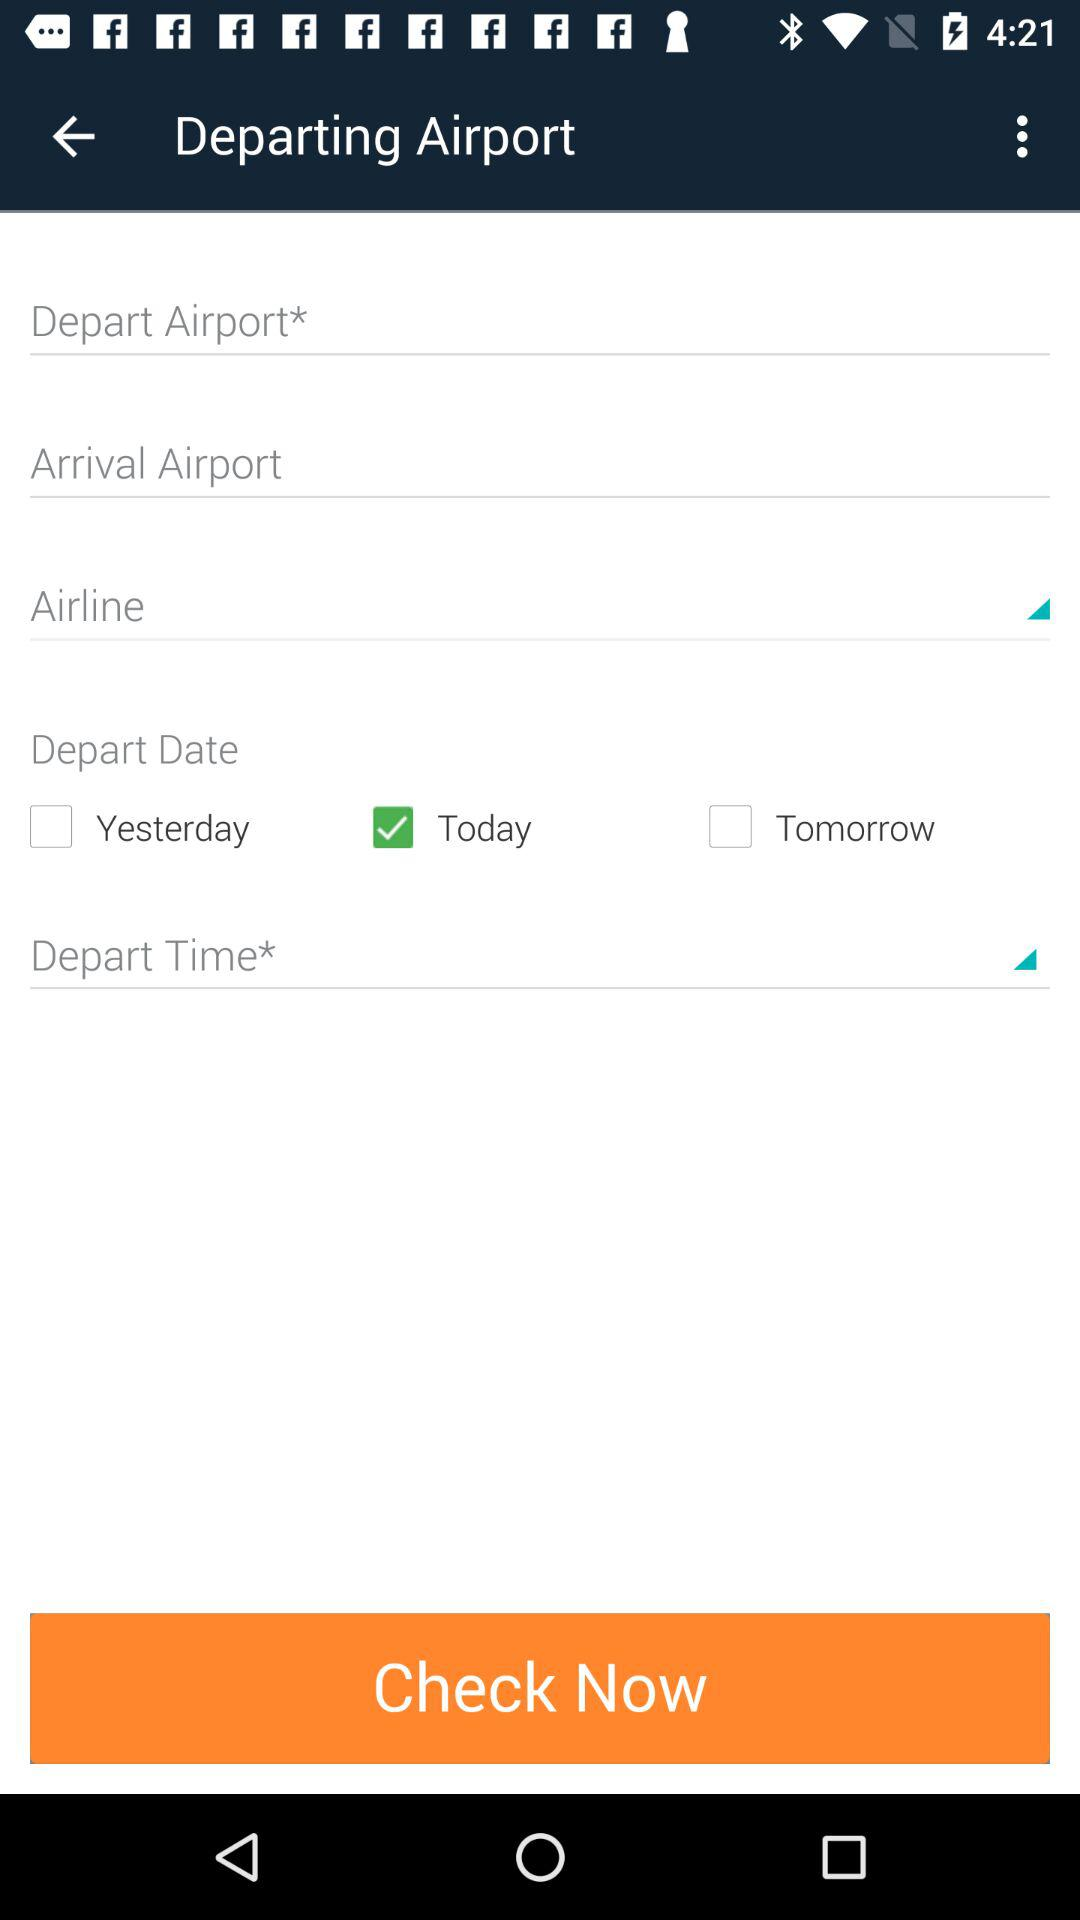What option is selected for "Depart Date"? The selected option is "Today". 